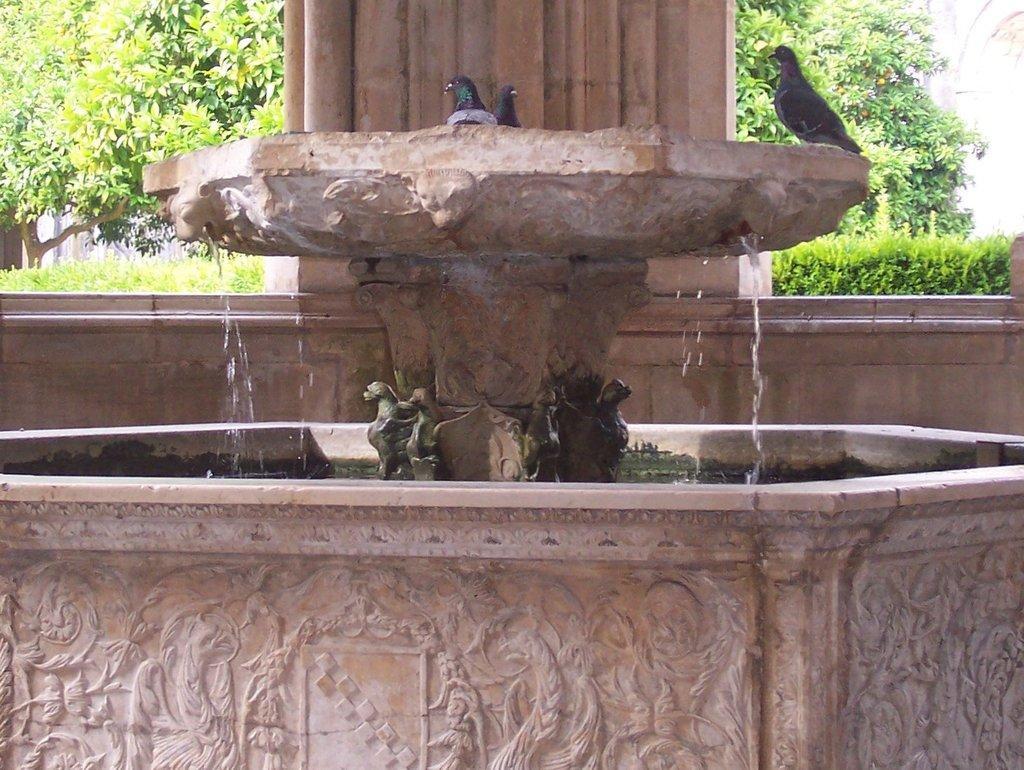How would you summarize this image in a sentence or two? In this image we can see there are birds on the surface. There is water. There is a pillar. In the background we can see trees and bushes. 